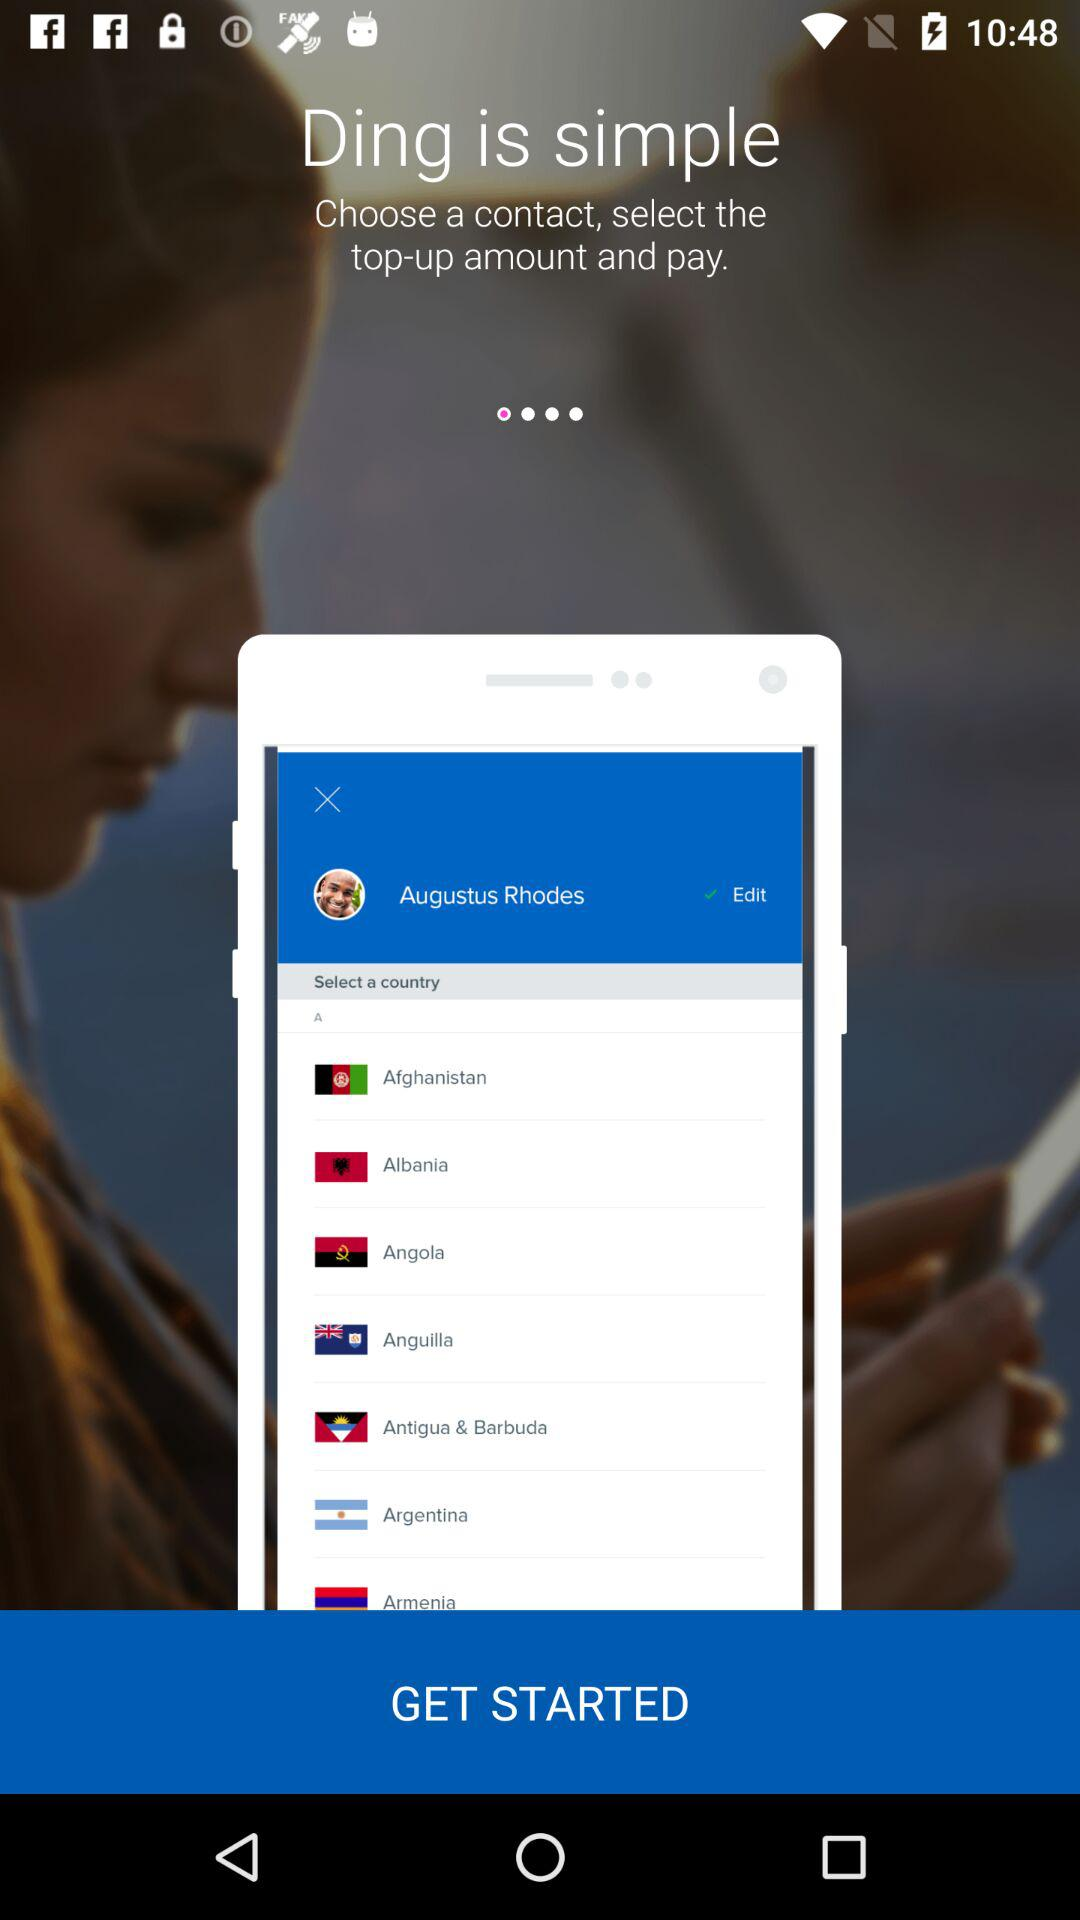What is the name of the application? The name of the application is "Ding". 